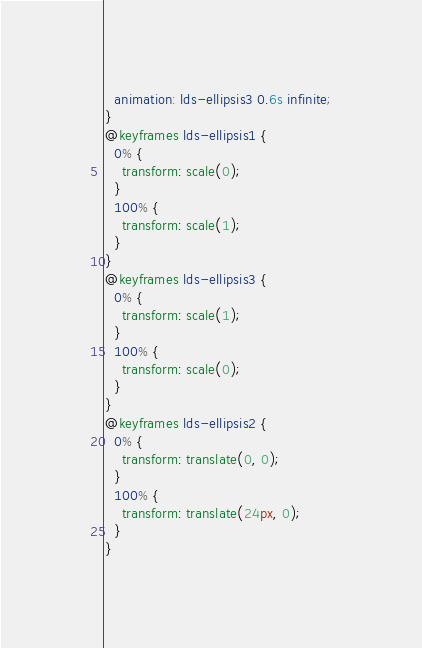Convert code to text. <code><loc_0><loc_0><loc_500><loc_500><_CSS_>  animation: lds-ellipsis3 0.6s infinite;
}
@keyframes lds-ellipsis1 {
  0% {
    transform: scale(0);
  }
  100% {
    transform: scale(1);
  }
}
@keyframes lds-ellipsis3 {
  0% {
    transform: scale(1);
  }
  100% {
    transform: scale(0);
  }
}
@keyframes lds-ellipsis2 {
  0% {
    transform: translate(0, 0);
  }
  100% {
    transform: translate(24px, 0);
  }
}

</code> 